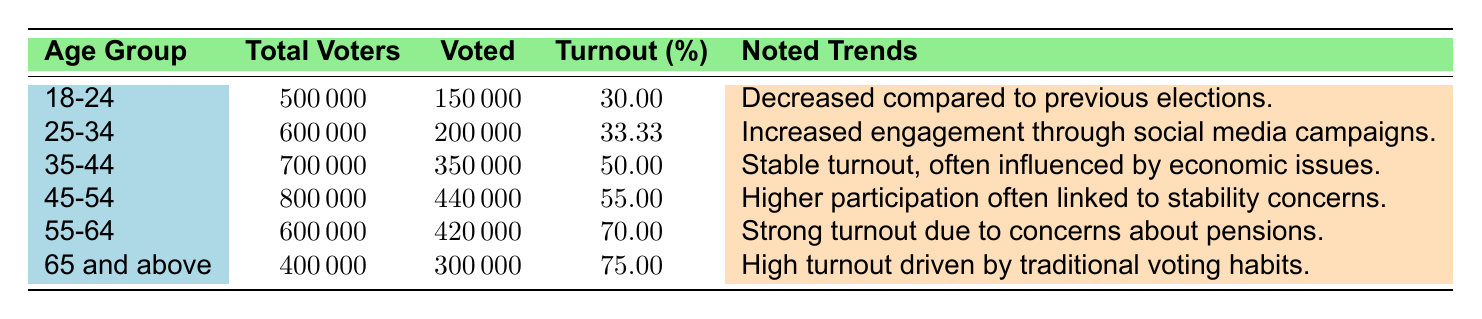What is the voter turnout percentage for the age group 18-24? The table shows that the turnout percentage for the age group 18-24 is explicitly listed as 30.00%.
Answer: 30.00% Which age group had the highest voter turnout in the 2022 General Elections? According to the table, the age group 65 and above had the highest voter turnout percentage at 75.00%.
Answer: 65 and above How many total voters were there in the age group 45-54? The table indicates that there were 800,000 total voters in the age group 45-54.
Answer: 800,000 What was the voter turnout for the age group 55-64 compared to the 25-34 age group? The turnout for the age group 55-64 was 70.00%, while for the 25-34 age group it was 33.33%. The turnout for 55-64 is significantly higher than for 25-34.
Answer: Higher for 55-64 What is the total number of voters across all age groups? We sum the total voters for each age group: 500,000 (18-24) + 600,000 (25-34) + 700,000 (35-44) + 800,000 (45-54) + 600,000 (55-64) + 400,000 (65 and above) = 3,600,000 total voters.
Answer: 3,600,000 Which age group saw a decrease in voter turnout compared to previous elections? The table notes that the age group 18-24 experienced a decrease in turnout compared to previous elections.
Answer: 18-24 What percentage of the total voters in the age group 35-44 voted in the elections? The table shows that 350,000 out of 700,000 total voters in the 35-44 age group voted, which is 50.00%.
Answer: 50.00% Is there a noted trend of increased engagement through social media campaigns in any age group? Yes, the table notes that the 25-34 age group had increased engagement through social media campaigns.
Answer: Yes If we compare the turnout percentages for the age groups 45-54 and 55-64, which age group had a higher percentage? The turnout for the age group 45-54 was 55.00%, while for the 55-64 age group it was 70.00%. Thus, 55-64 had a higher percentage.
Answer: 55-64 What is the difference in voter turnout percentage between the age groups 65 and above and 55-64? The turnout for 65 and above is 75.00% and for 55-64 it is 70.00%. The difference is 75.00% - 70.00% = 5.00%.
Answer: 5.00% How many voters in the age group 25-34 voted? The table indicates that in the age group 25-34, 200,000 voters participated in the elections.
Answer: 200,000 